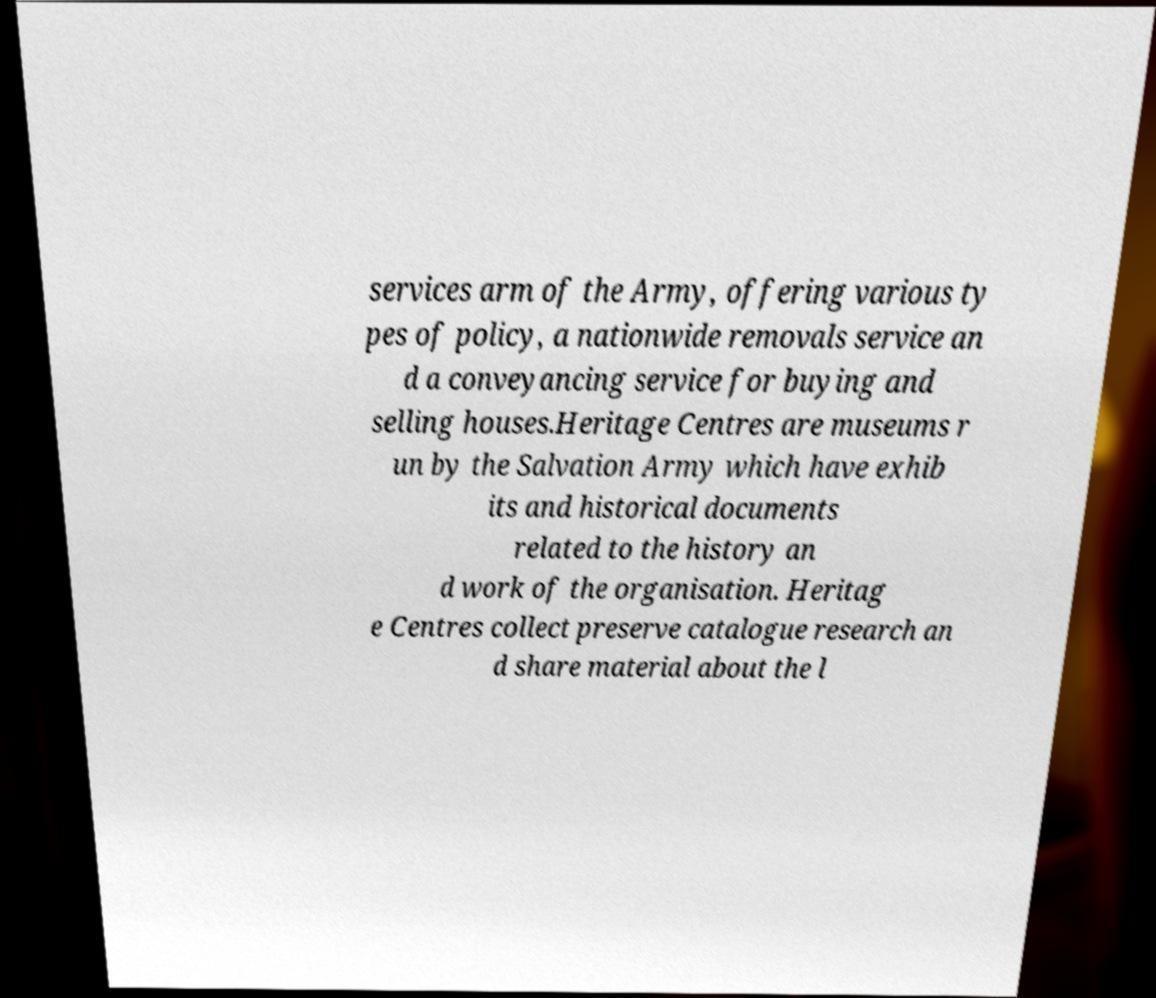Can you accurately transcribe the text from the provided image for me? services arm of the Army, offering various ty pes of policy, a nationwide removals service an d a conveyancing service for buying and selling houses.Heritage Centres are museums r un by the Salvation Army which have exhib its and historical documents related to the history an d work of the organisation. Heritag e Centres collect preserve catalogue research an d share material about the l 